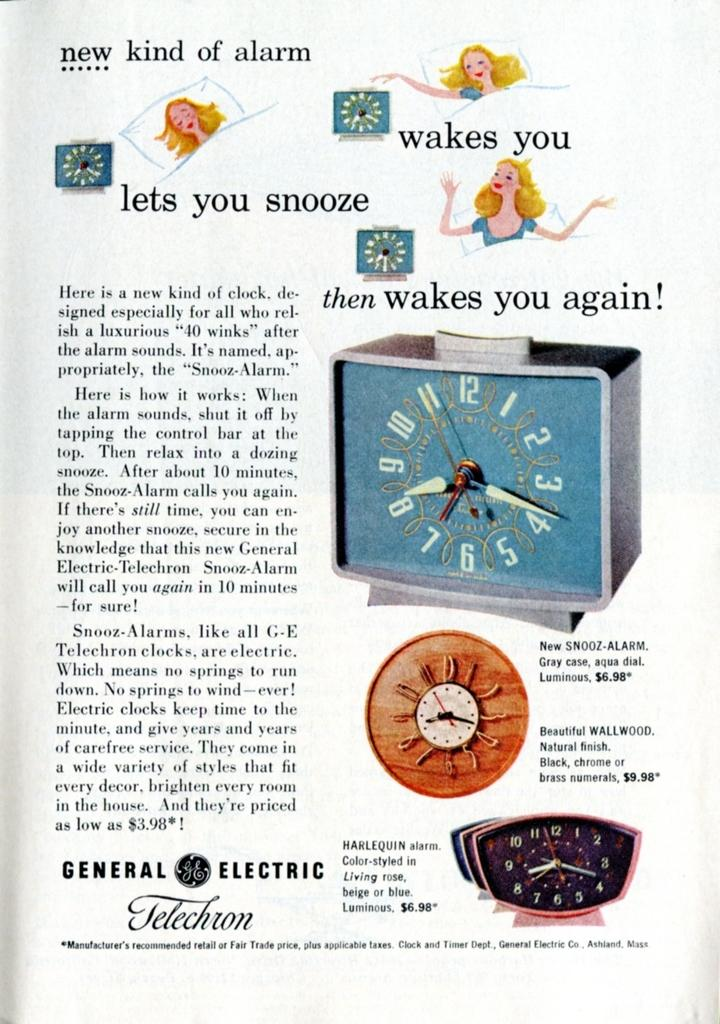<image>
Provide a brief description of the given image. An advertisement for GE's Telechron features an illustration of a woman. 